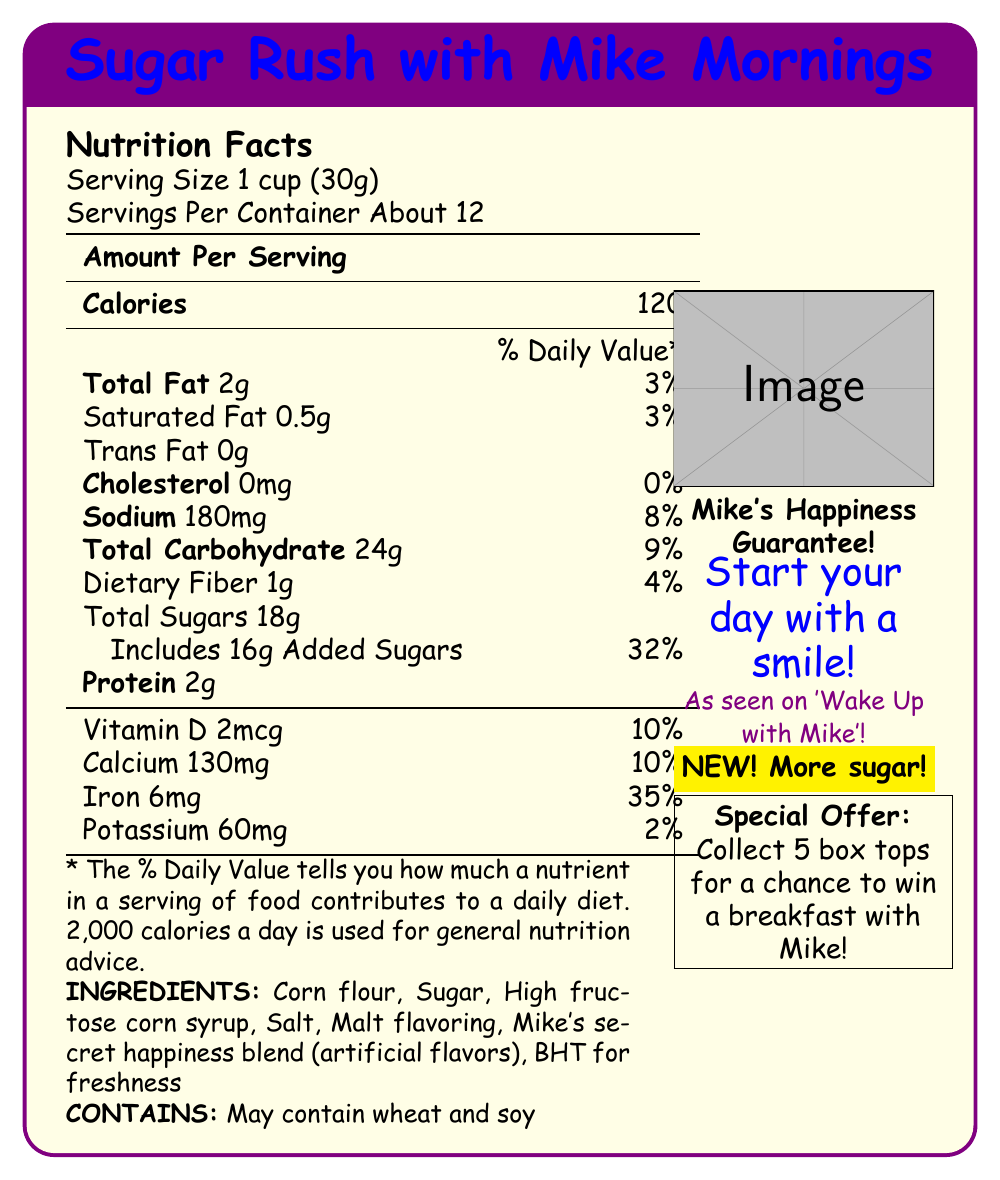1. What is the serving size for "Sugar Rush with Mike Mornings"? The serving size is mentioned at the top of the Nutrition Facts section as "Serving Size 1 cup (30g)".
Answer: 1 cup (30g) 2. How many servings are there per container? The number of servings per container is listed right below the serving size as "Servings Per Container About 12".
Answer: About 12 3. How much total sugar does one serving of the cereal contain? The total sugars per serving is listed under the Total Carbohydrate section as "Total Sugars 18g".
Answer: 18g 4. What percentage of the daily value of added sugars is in one serving? The daily value percentage for added sugars is noted beside the added sugars amount as "Includes 16g Added Sugars 32%".
Answer: 32% 5. Name two ingredients in the cereal other than sugar and high fructose corn syrup. The ingredients list includes these ingredients: Corn flour, Sugar, High fructose corn syrup, Salt, Malt flavoring, Mike's secret happiness blend (artificial flavors), BHT for freshness.
Answer: Corn flour, Salt 6. What is the calorie content per serving of this cereal? The calorie content per serving is listed at the top of the Nutrition Facts section as "Calories 120".
Answer: 120 7. Which nutrient has the highest daily value percentage per serving? A. Sodium B. Calcium C. Iron D. Potassium The daily value percentage for Iron is the highest at 35%, compared to other nutrients listed.
Answer: C. Iron 8. What is featured on the box of "Sugar Rush with Mike Mornings"? A. Mike's smiling face with thumbs up B. A cartoon character C. A gold star with "NEW! Less sugar!" text The box features described include "Mike's smiling face with thumbs up" and "Gold star burst with 'NEW! More sugar!' text", among others.
Answer: A. Mike's smiling face with thumbs up 9. Can this cereal be considered low in sodium? Yes/No The sodium content is 180mg per serving, which is 8% of the daily value. Generally, low sodium foods contain less than 140mg per serving.
Answer: No 10. What would be a summary of all the information presented in this document? This document provides a comprehensive look at the nutrition facts, ingredients, promotional offers, and marketing claims for the "Sugar Rush with Mike Mornings" breakfast cereal. It highlights the high sugar content prominently, includes precise nutritional details, a list of ingredients, and key allergy information. The cereal is heavily marketed with the TV show host's image and emphasizes themes of happiness and enthusiasm.
Answer: A breakfast cereal called "Sugar Rush with Mike Mornings" featuring TV show host Mike's face on the box, highlights a high sugar content of 18g per serving, includes 16g added sugars (32% daily value), provides 120 calories per serving, and offers a special promotional offer to win breakfast with Mike by collecting box tops. Nutritional Information includes details on fats, sodium, carbohydrates, protein, vitamins, minerals, ingredients, and allergen information. Marketing claims emphasize happiness and starting the day with a smile. 11. Are the exact artificial flavors in "Mike's secret happiness blend" listed? The document only mentions "Mike's secret happiness blend (artificial flavors)" but does not provide details on the exact artificial flavors included.
Answer: Not enough information 